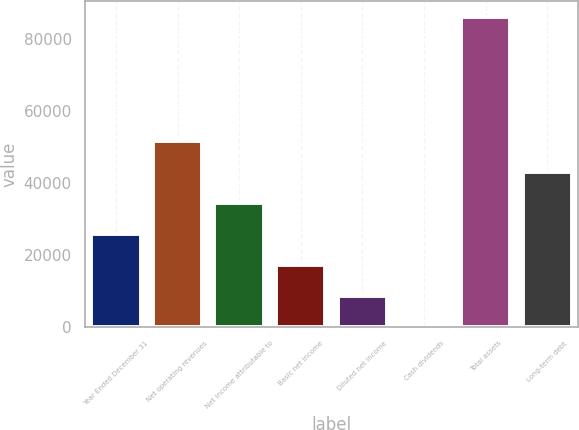Convert chart to OTSL. <chart><loc_0><loc_0><loc_500><loc_500><bar_chart><fcel>Year Ended December 31<fcel>Net operating revenues<fcel>Net income attributable to<fcel>Basic net income<fcel>Diluted net income<fcel>Cash dividends<fcel>Total assets<fcel>Long-term debt<nl><fcel>25843.6<fcel>51686.2<fcel>34457.8<fcel>17229.4<fcel>8615.22<fcel>1.02<fcel>86143<fcel>43072<nl></chart> 